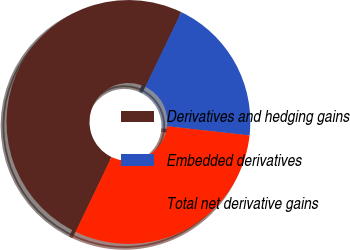<chart> <loc_0><loc_0><loc_500><loc_500><pie_chart><fcel>Derivatives and hedging gains<fcel>Embedded derivatives<fcel>Total net derivative gains<nl><fcel>50.0%<fcel>19.62%<fcel>30.38%<nl></chart> 